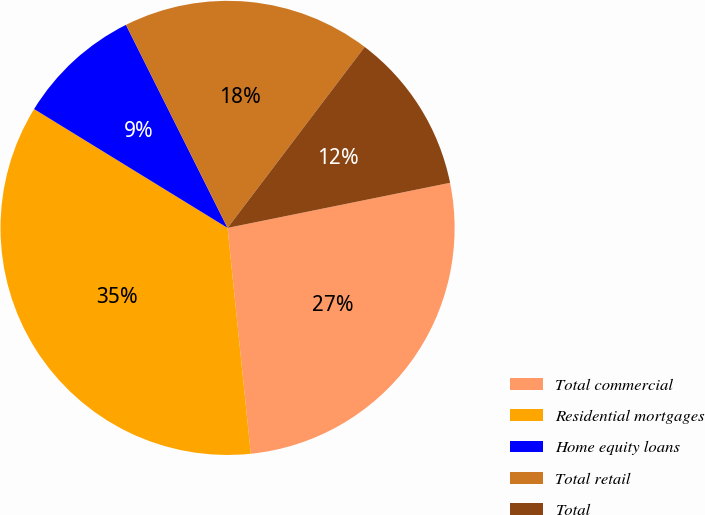<chart> <loc_0><loc_0><loc_500><loc_500><pie_chart><fcel>Total commercial<fcel>Residential mortgages<fcel>Home equity loans<fcel>Total retail<fcel>Total<nl><fcel>26.55%<fcel>35.4%<fcel>8.85%<fcel>17.7%<fcel>11.5%<nl></chart> 